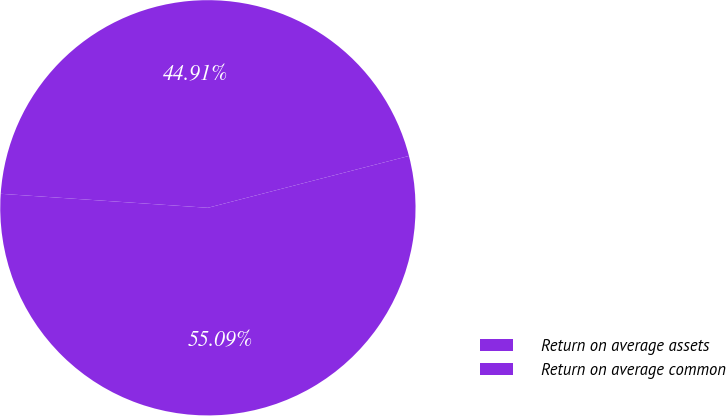Convert chart to OTSL. <chart><loc_0><loc_0><loc_500><loc_500><pie_chart><fcel>Return on average assets<fcel>Return on average common<nl><fcel>44.91%<fcel>55.09%<nl></chart> 